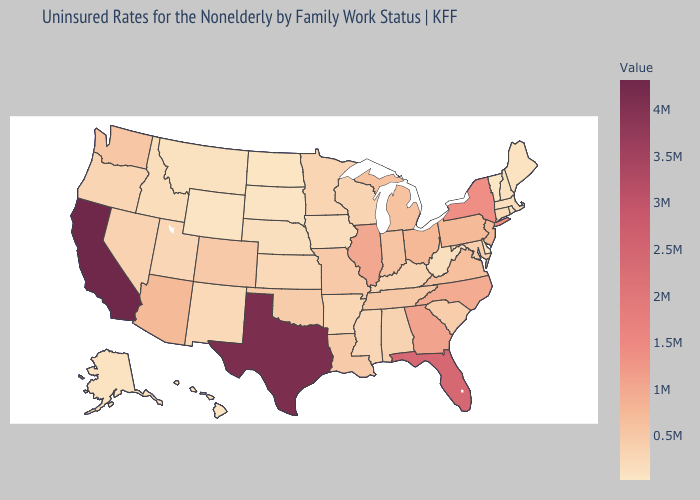Is the legend a continuous bar?
Keep it brief. Yes. Does Indiana have the highest value in the USA?
Give a very brief answer. No. Among the states that border Delaware , which have the lowest value?
Give a very brief answer. Maryland. Among the states that border Washington , does Idaho have the highest value?
Short answer required. No. Which states have the lowest value in the South?
Answer briefly. Delaware. Which states hav the highest value in the West?
Quick response, please. California. Among the states that border New Jersey , which have the highest value?
Give a very brief answer. New York. 